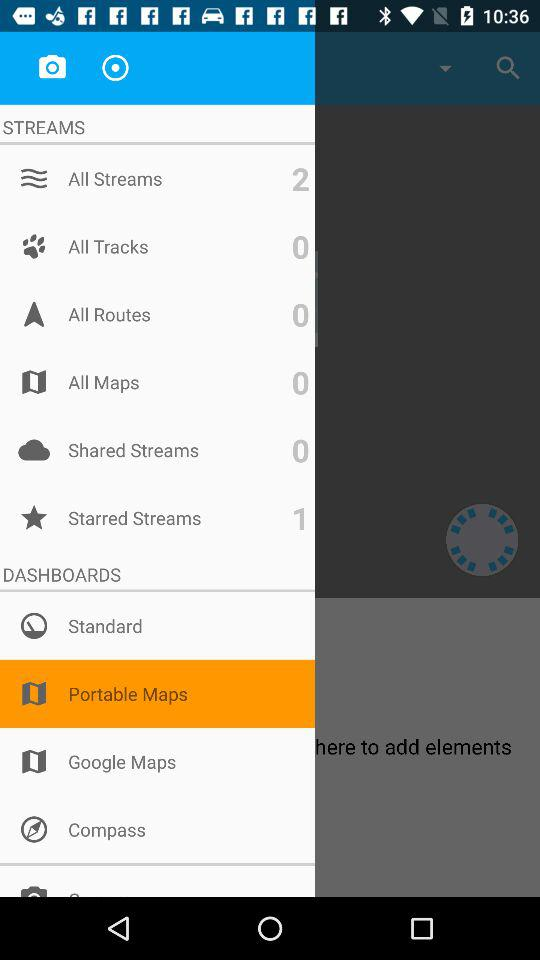How many starred streams in total are there? There is one starred stream. 